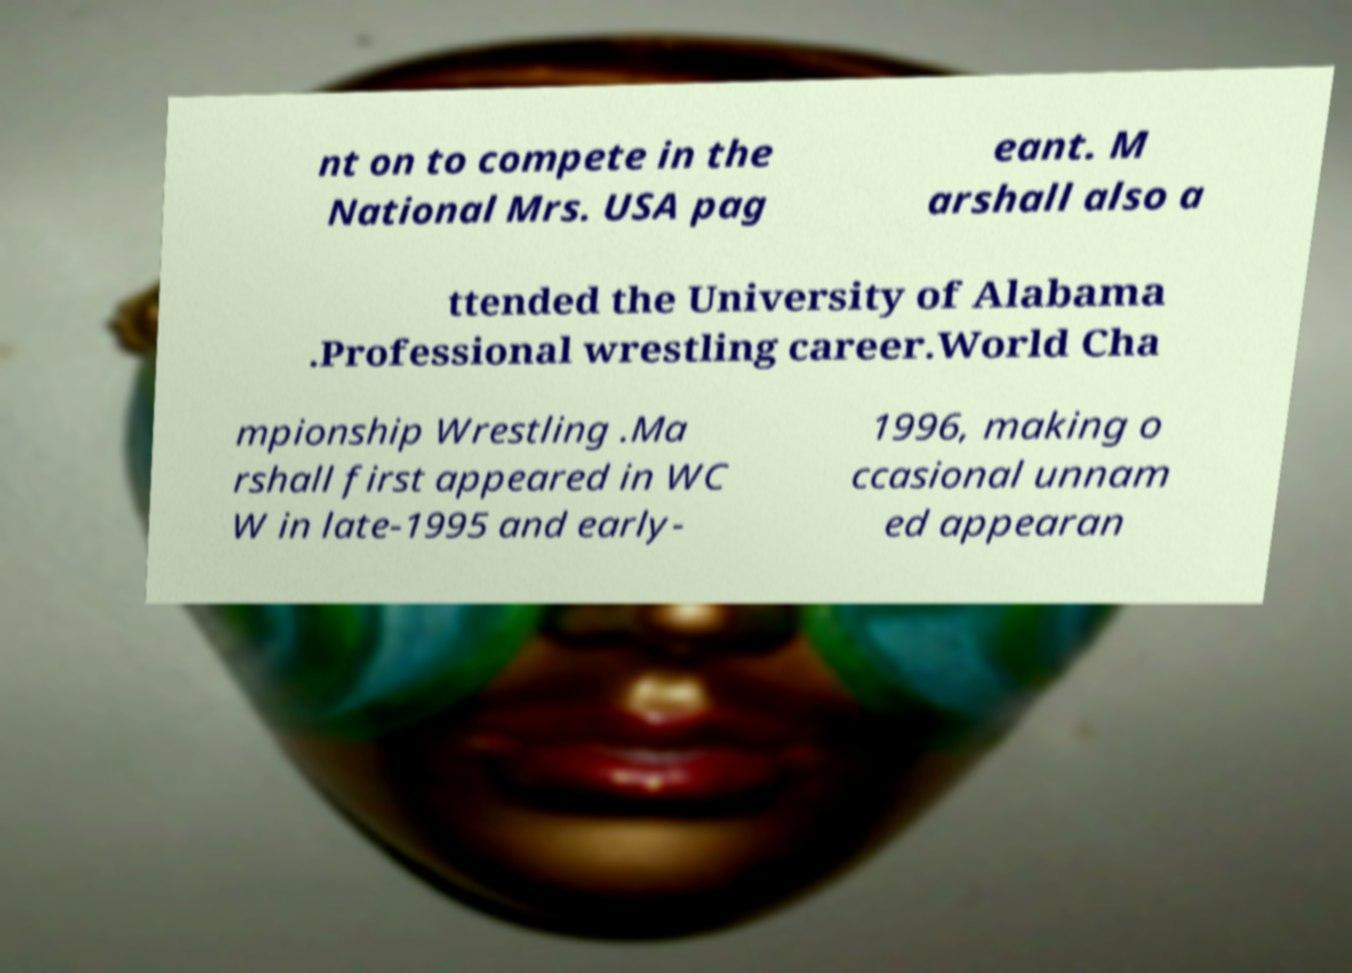For documentation purposes, I need the text within this image transcribed. Could you provide that? nt on to compete in the National Mrs. USA pag eant. M arshall also a ttended the University of Alabama .Professional wrestling career.World Cha mpionship Wrestling .Ma rshall first appeared in WC W in late-1995 and early- 1996, making o ccasional unnam ed appearan 